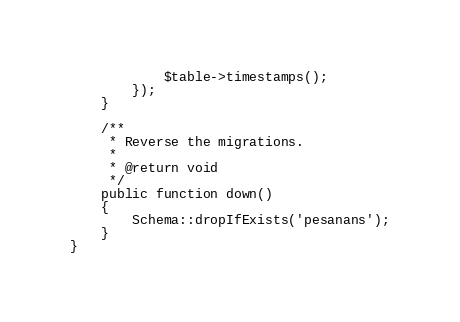<code> <loc_0><loc_0><loc_500><loc_500><_PHP_>            $table->timestamps();
        });
    }

    /**
     * Reverse the migrations.
     *
     * @return void
     */
    public function down()
    {
        Schema::dropIfExists('pesanans');
    }
}
</code> 